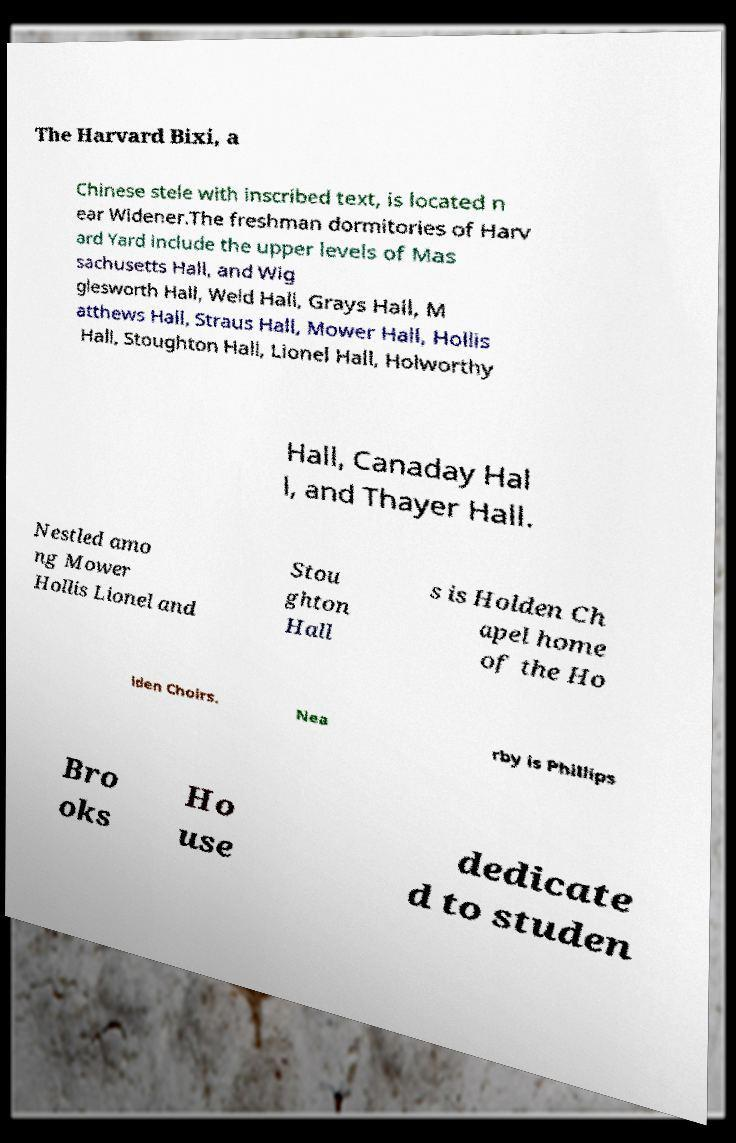Can you accurately transcribe the text from the provided image for me? The Harvard Bixi, a Chinese stele with inscribed text, is located n ear Widener.The freshman dormitories of Harv ard Yard include the upper levels of Mas sachusetts Hall, and Wig glesworth Hall, Weld Hall, Grays Hall, M atthews Hall, Straus Hall, Mower Hall, Hollis Hall, Stoughton Hall, Lionel Hall, Holworthy Hall, Canaday Hal l, and Thayer Hall. Nestled amo ng Mower Hollis Lionel and Stou ghton Hall s is Holden Ch apel home of the Ho lden Choirs. Nea rby is Phillips Bro oks Ho use dedicate d to studen 